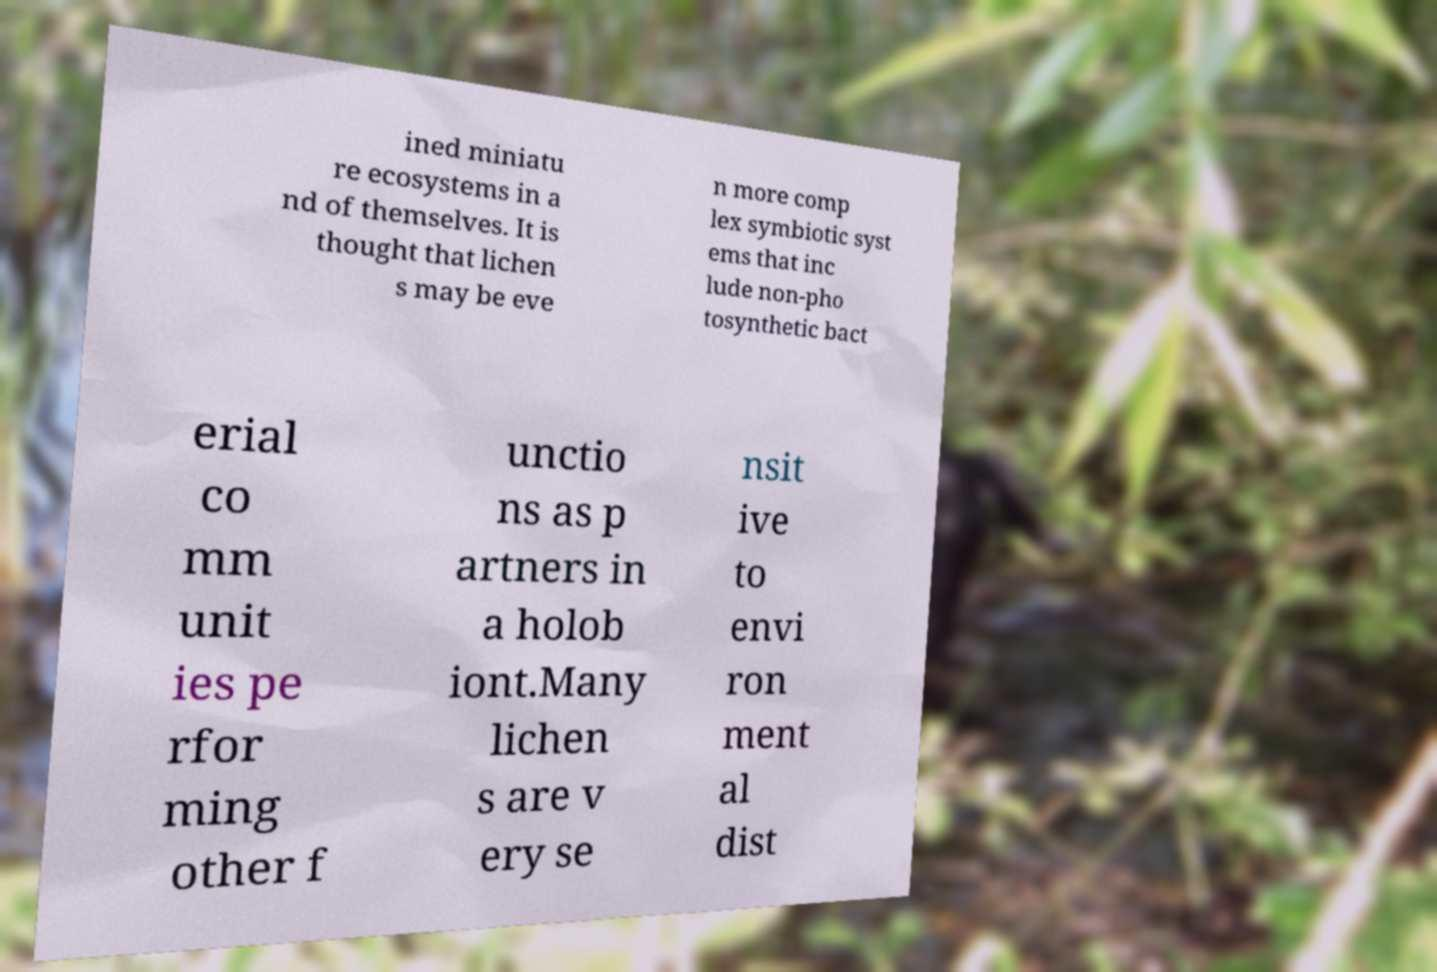Can you accurately transcribe the text from the provided image for me? ined miniatu re ecosystems in a nd of themselves. It is thought that lichen s may be eve n more comp lex symbiotic syst ems that inc lude non-pho tosynthetic bact erial co mm unit ies pe rfor ming other f unctio ns as p artners in a holob iont.Many lichen s are v ery se nsit ive to envi ron ment al dist 